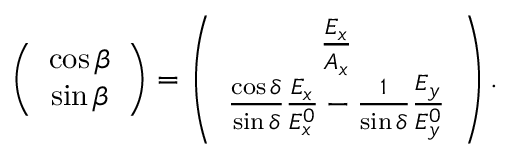Convert formula to latex. <formula><loc_0><loc_0><loc_500><loc_500>\begin{array} { r } { \left ( \begin{array} { c } { \cos \beta } \\ { \sin \beta } \end{array} \right ) = \left ( \begin{array} { c } { \frac { E _ { x } } { A _ { x } } } \\ { \frac { \cos \delta } { \sin \delta } \frac { E _ { x } } { E _ { x } ^ { 0 } } - \frac { 1 } { \sin \delta } \frac { E _ { y } } { E _ { y } ^ { 0 } } } \end{array} \right ) . } \end{array}</formula> 